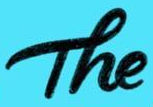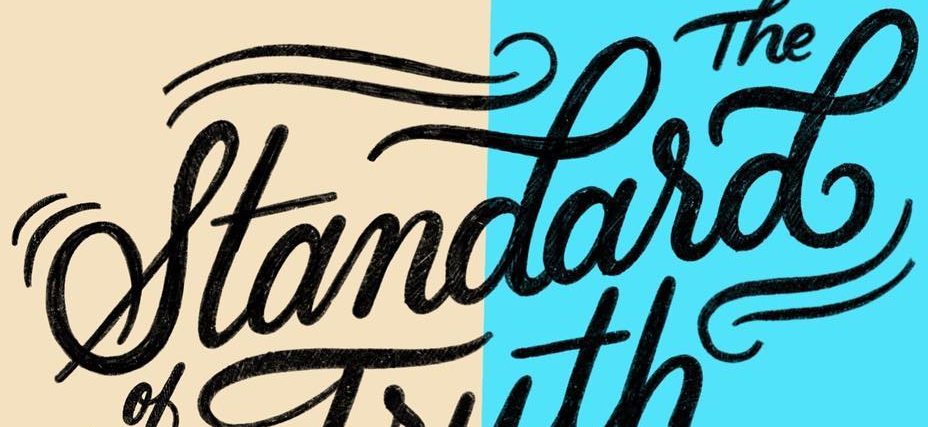Read the text content from these images in order, separated by a semicolon. The; standasd 